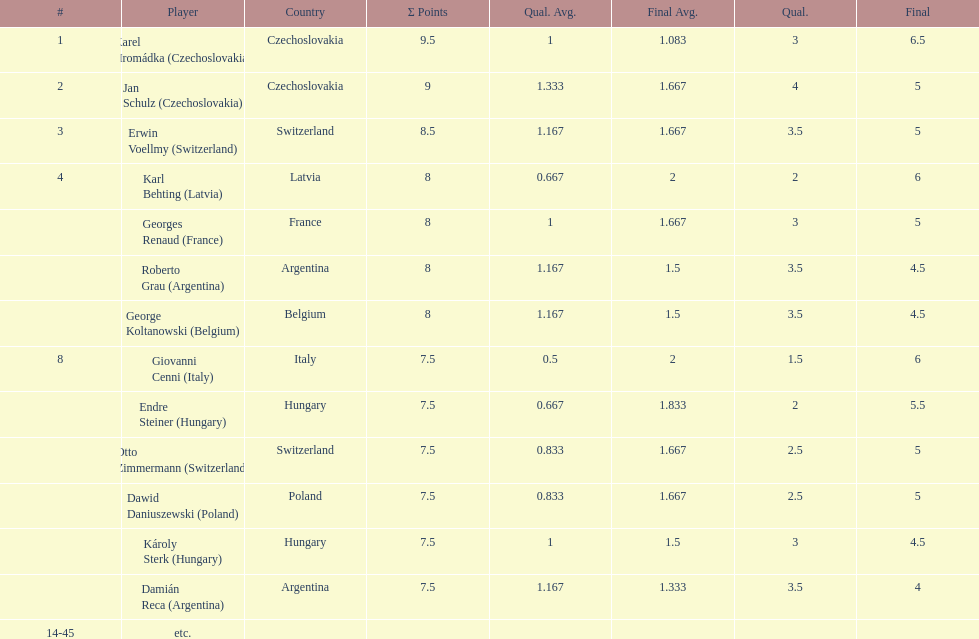Parse the table in full. {'header': ['#', 'Player', 'Country', 'Σ Points', 'Qual. Avg.', 'Final Avg.', 'Qual.', 'Final'], 'rows': [['1', 'Karel Hromádka\xa0(Czechoslovakia)', 'Czechoslovakia', '9.5', '1', '1.083', '3', '6.5'], ['2', 'Jan Schulz\xa0(Czechoslovakia)', 'Czechoslovakia', '9', '1.333', '1.667', '4', '5'], ['3', 'Erwin Voellmy\xa0(Switzerland)', 'Switzerland', '8.5', '1.167', '1.667', '3.5', '5'], ['4', 'Karl Behting\xa0(Latvia)', 'Latvia', '8', '0.667', '2', '2', '6'], ['', 'Georges Renaud\xa0(France)', 'France', '8', '1', '1.667', '3', '5'], ['', 'Roberto Grau\xa0(Argentina)', 'Argentina', '8', '1.167', '1.5', '3.5', '4.5'], ['', 'George Koltanowski\xa0(Belgium)', 'Belgium', '8', '1.167', '1.5', '3.5', '4.5'], ['8', 'Giovanni Cenni\xa0(Italy)', 'Italy', '7.5', '0.5', '2', '1.5', '6'], ['', 'Endre Steiner\xa0(Hungary)', 'Hungary', '7.5', '0.667', '1.833', '2', '5.5'], ['', 'Otto Zimmermann\xa0(Switzerland)', 'Switzerland', '7.5', '0.833', '1.667', '2.5', '5'], ['', 'Dawid Daniuszewski\xa0(Poland)', 'Poland', '7.5', '0.833', '1.667', '2.5', '5'], ['', 'Károly Sterk\xa0(Hungary)', 'Hungary', '7.5', '1', '1.5', '3', '4.5'], ['', 'Damián Reca\xa0(Argentina)', 'Argentina', '7.5', '1.167', '1.333', '3.5', '4'], ['14-45', 'etc.', '', '', '', '', '', '']]} Which player had the largest number of &#931; points? Karel Hromádka. 